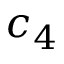Convert formula to latex. <formula><loc_0><loc_0><loc_500><loc_500>c _ { 4 }</formula> 